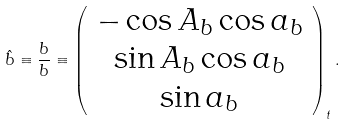<formula> <loc_0><loc_0><loc_500><loc_500>\hat { b } \equiv \frac { b } { b } \equiv \left ( \begin{array} { c } - \cos A _ { b } \cos a _ { b } \\ \sin A _ { b } \cos a _ { b } \\ \sin a _ { b } \\ \end{array} \right ) _ { t } .</formula> 